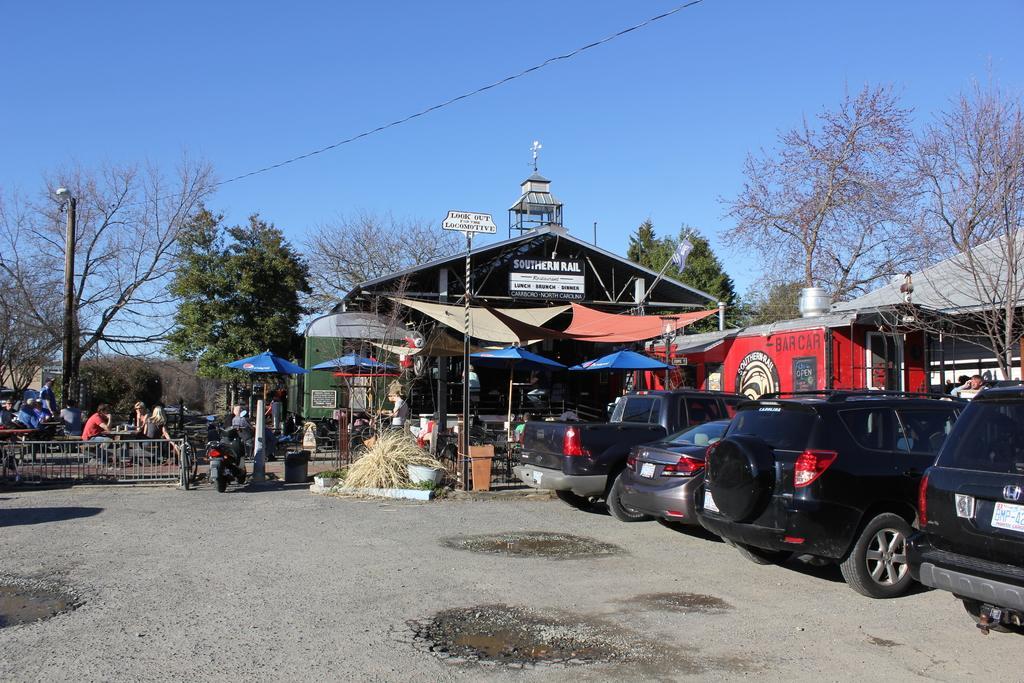Can you describe this image briefly? This image is clicked on the road. To the right there are vehicles parked on the road. Behind the vehicles there are houses. There are table umbrellas and chairs. There are people sitting on the chairs. Beside the road there is a railing. There are street light poles and sign board poles. Behind the houses there are trees. At the top there is the sky. 